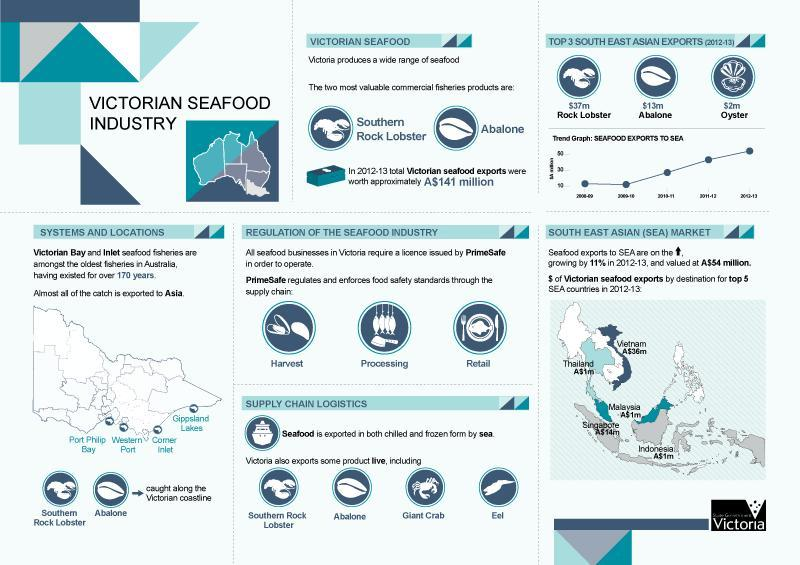Which South East Asian country has the second highest worth for victorian seafood exports in 2012-13?
Answer the question with a short phrase. Singapore Which is the top product in the southeast asian exports(2012-13)? Rock Lobster Which South East Asian country has the highest worth for victorian seafood exports in 2012-13? Vietnam What is the worth of total victorian seafood exports  in the year 2012-13? approximately A$141 million Which authority is issuing the license for all seafood businesses in Victoria? PrimeSafe What is the worth of victorian seafood exports in Malaysia in the year 2012-13? A$1m 